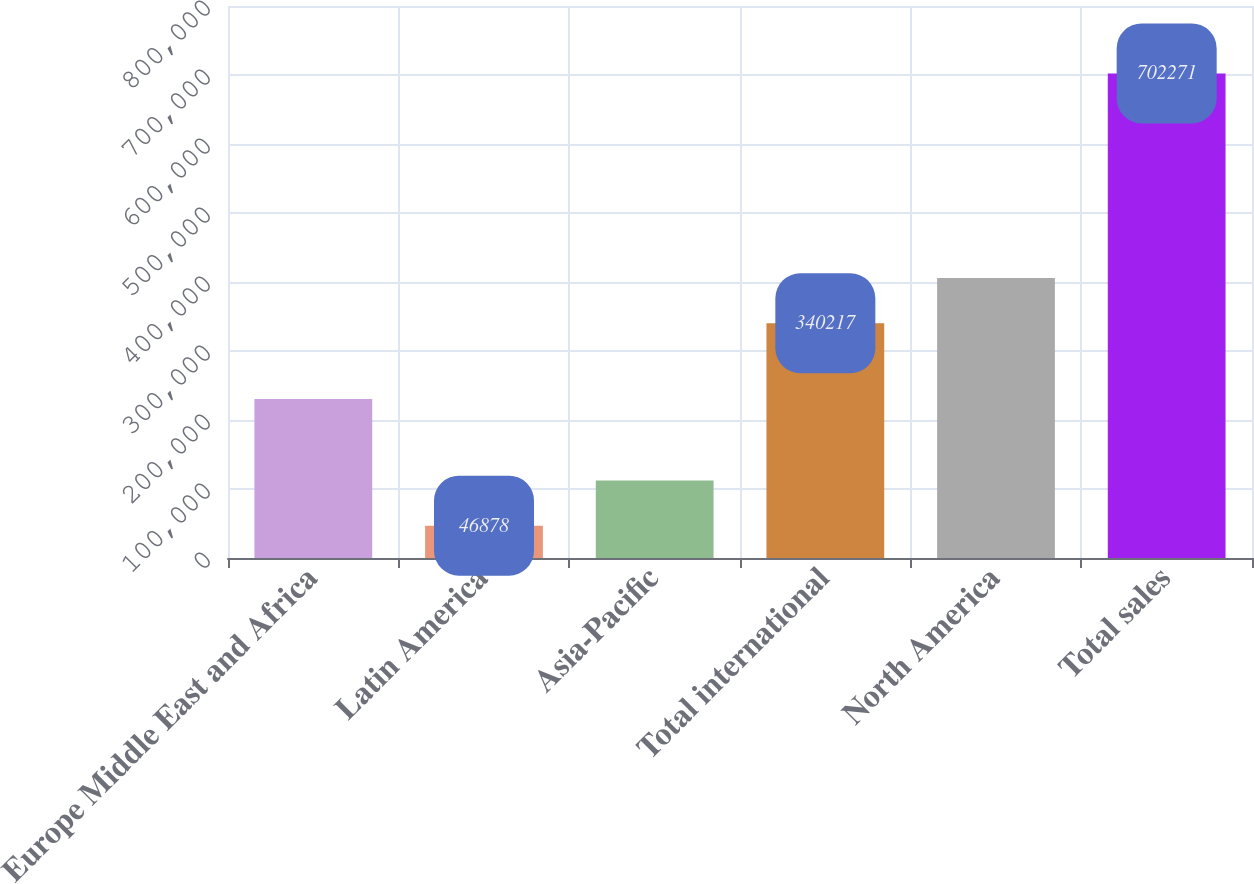<chart> <loc_0><loc_0><loc_500><loc_500><bar_chart><fcel>Europe Middle East and Africa<fcel>Latin America<fcel>Asia-Pacific<fcel>Total international<fcel>North America<fcel>Total sales<nl><fcel>230365<fcel>46878<fcel>112417<fcel>340217<fcel>405756<fcel>702271<nl></chart> 